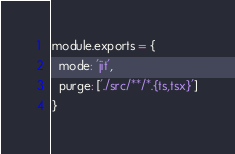<code> <loc_0><loc_0><loc_500><loc_500><_JavaScript_>module.exports = {
  mode: 'jit',
  purge: ['./src/**/*.{ts,tsx}']
}
</code> 